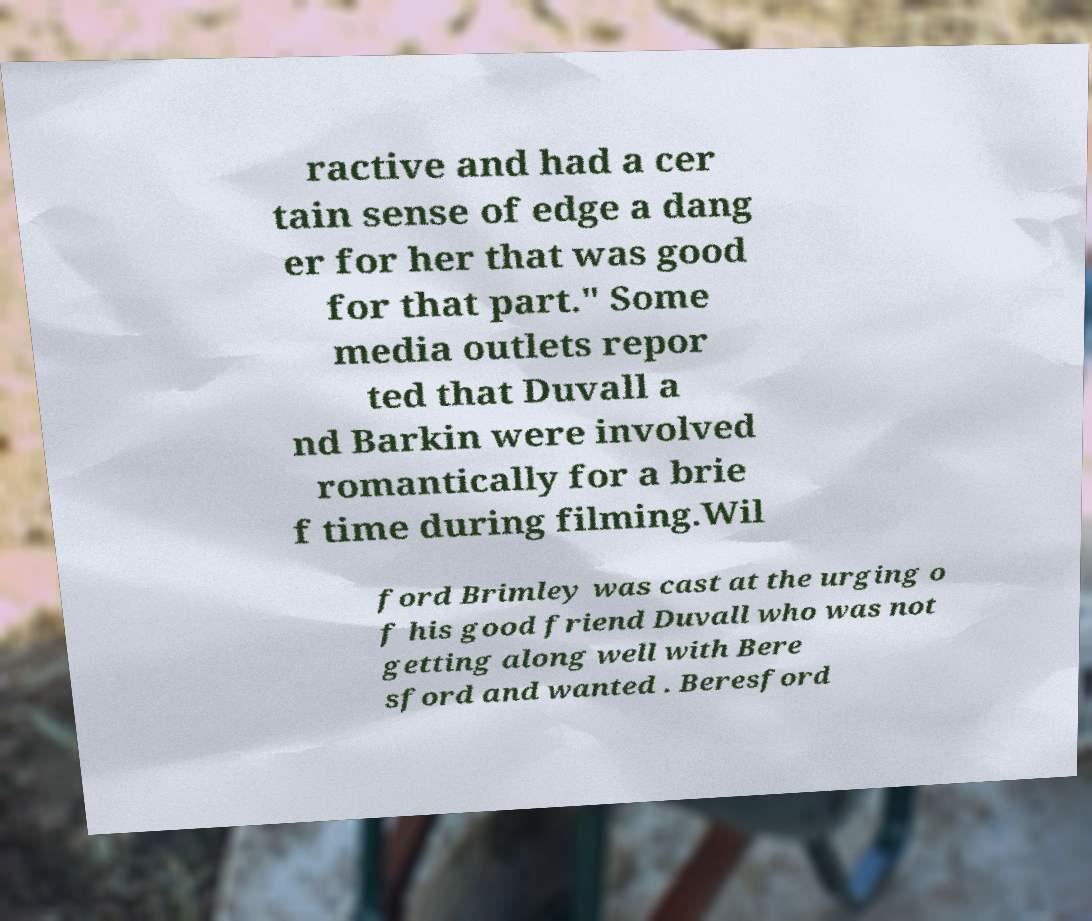Please read and relay the text visible in this image. What does it say? ractive and had a cer tain sense of edge a dang er for her that was good for that part." Some media outlets repor ted that Duvall a nd Barkin were involved romantically for a brie f time during filming.Wil ford Brimley was cast at the urging o f his good friend Duvall who was not getting along well with Bere sford and wanted . Beresford 